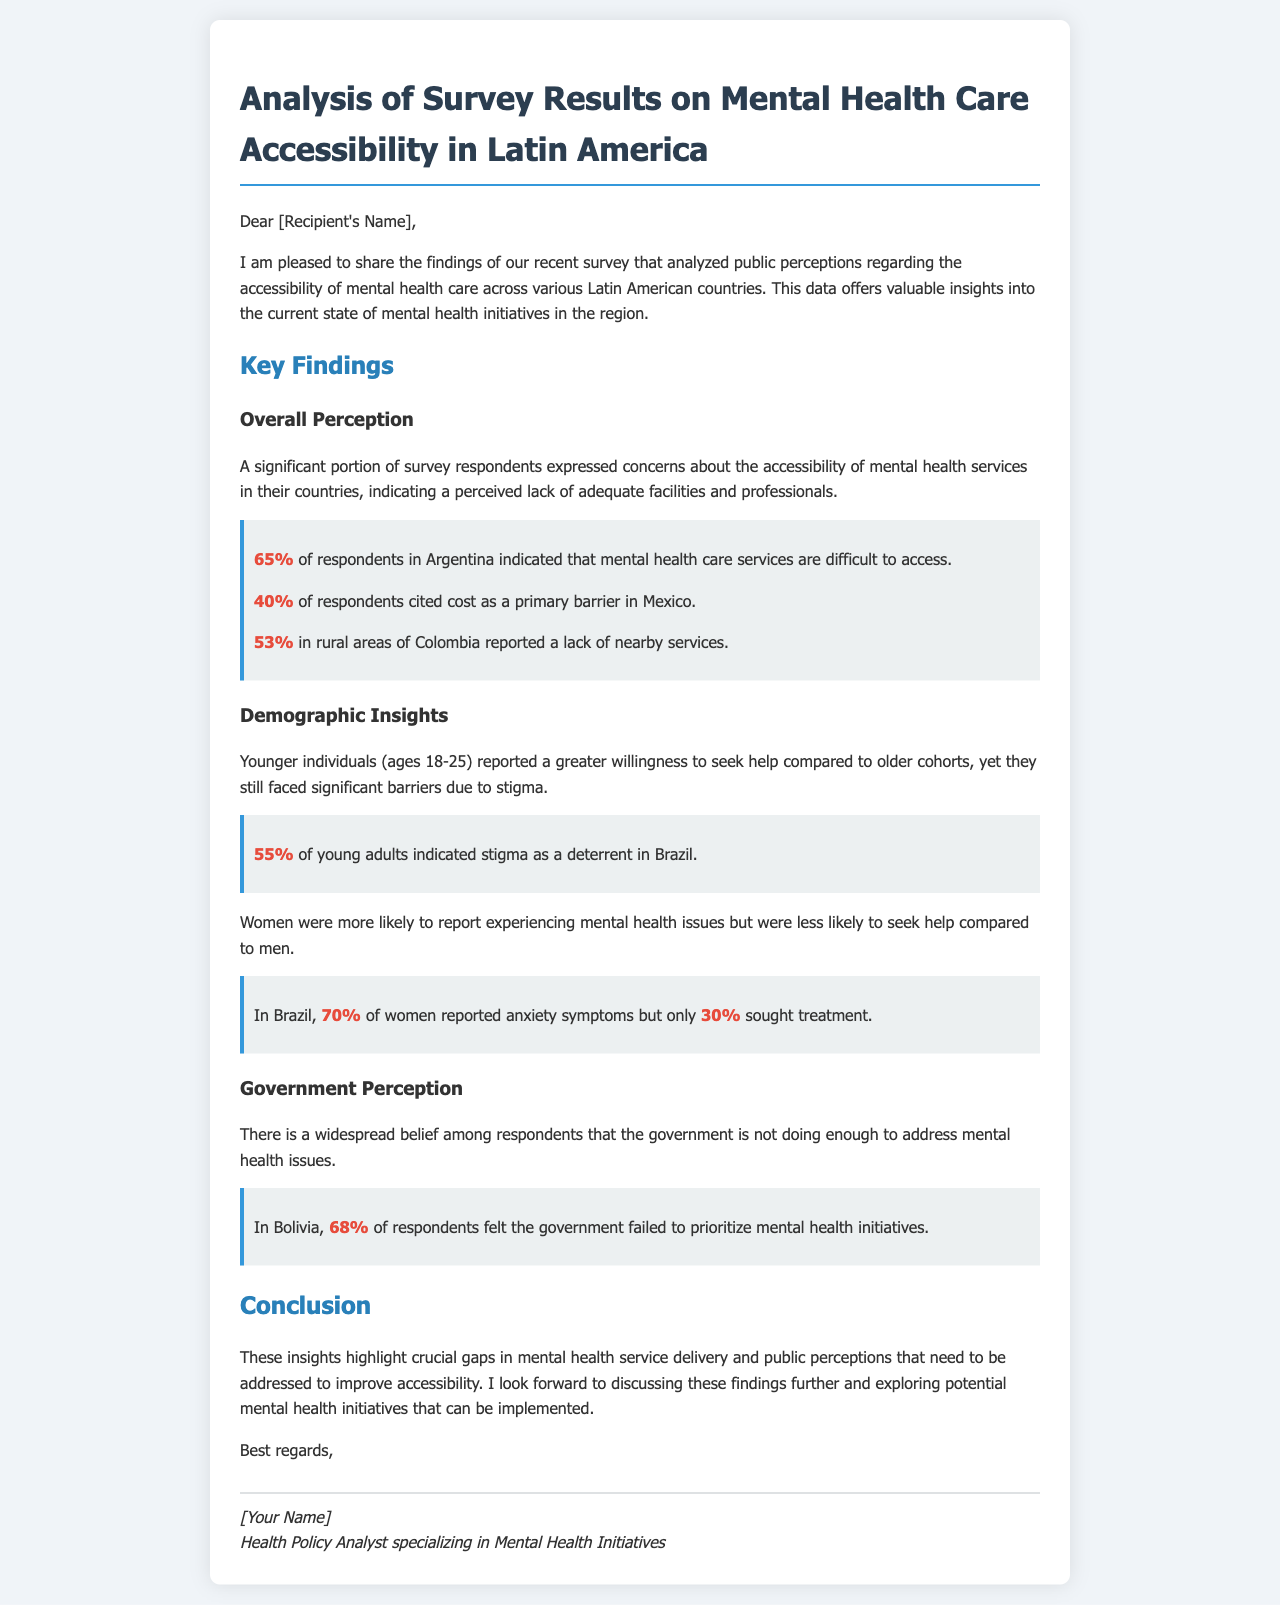what percentage of respondents in Argentina indicated difficulty accessing mental health care services? The document states that 65% of respondents in Argentina indicated that mental health care services are difficult to access.
Answer: 65% what is cited as a primary barrier to mental health care in Mexico? The document mentions that 40% of respondents in Mexico cited cost as a primary barrier.
Answer: cost what percentage of young adults in Brazil indicated stigma as a deterrent to seeking help? According to the document, 55% of young adults indicated stigma as a deterrent in Brazil.
Answer: 55% what did 70% of women in Brazil report experiencing? The document states that 70% of women in Brazil reported anxiety symptoms.
Answer: anxiety symptoms in which country did 68% of respondents feel the government failed to prioritize mental health initiatives? The document indicates that 68% of respondents in Bolivia felt the government failed to prioritize mental health initiatives.
Answer: Bolivia what is the main conclusion drawn from the survey results? The conclusion highlights crucial gaps in mental health service delivery and public perceptions that need to be addressed to improve accessibility.
Answer: gaps in mental health service delivery what demographic group showed a greater willingness to seek help? The document mentions that younger individuals (ages 18-25) reported a greater willingness to seek help.
Answer: younger individuals what did the salutation of the email include? The salutation of the email included "Dear [Recipient's Name],".
Answer: Dear [Recipient's Name] 